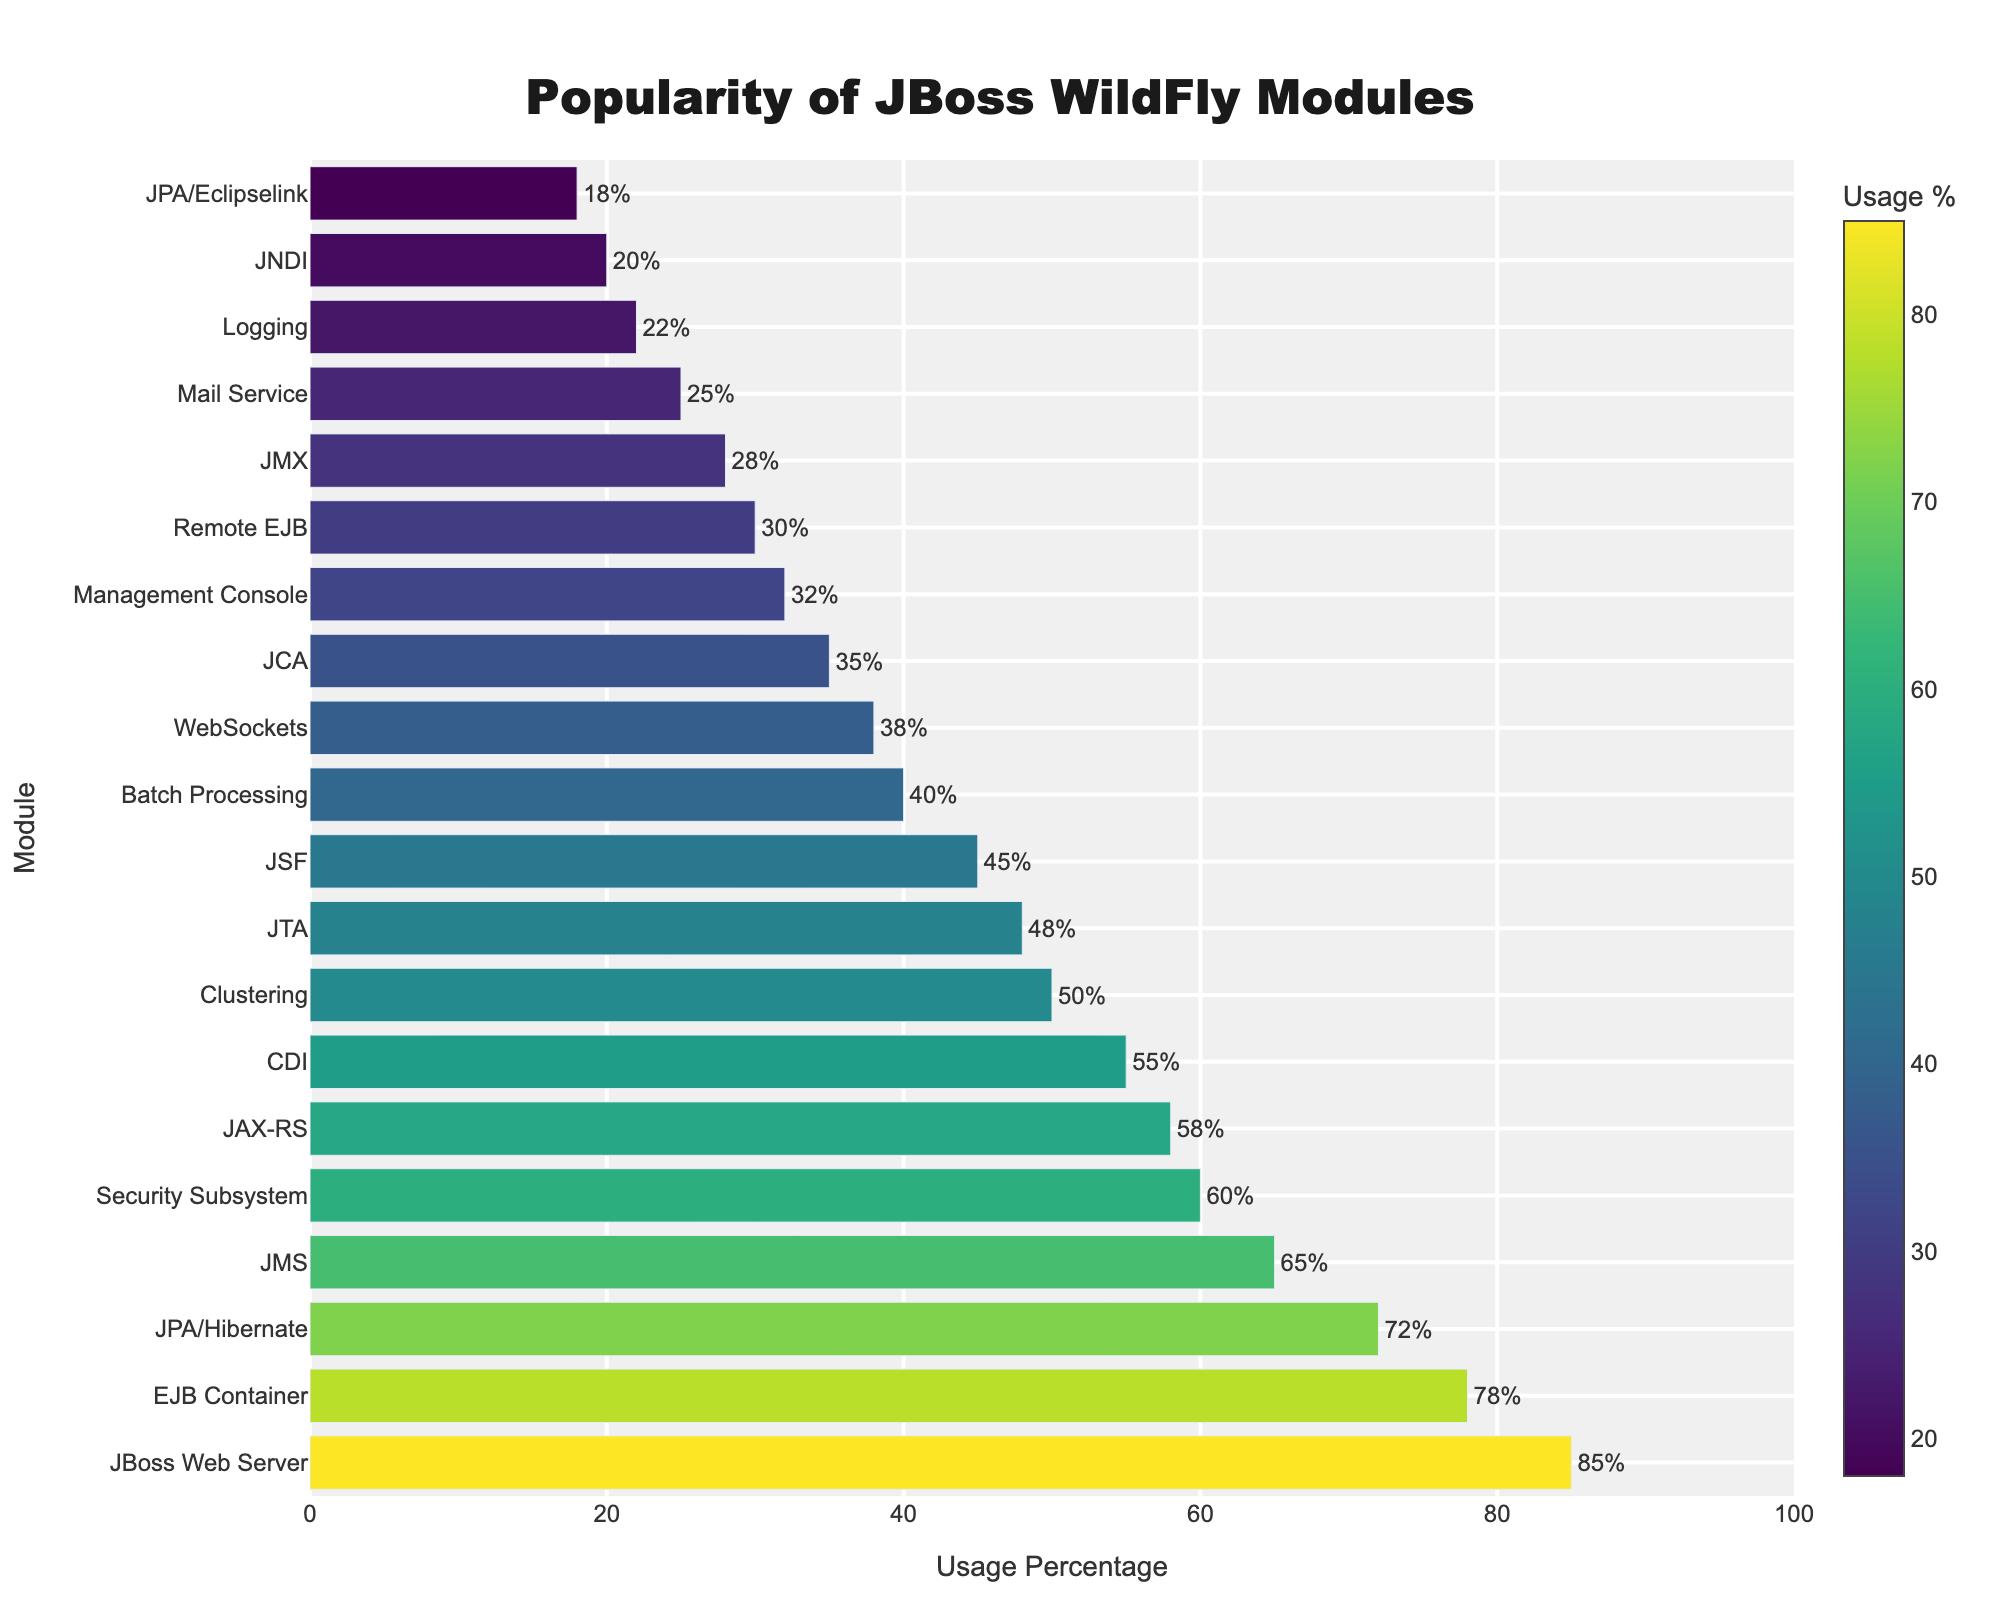Which module has the highest usage percentage? The JBoss Web Server module has the highest bar in the figure, indicating it has the highest usage percentage.
Answer: JBoss Web Server Which two modules have the closest usage percentages? By comparing the lengths of the bars, EJB Container (78%) and JPA/Hibernate (72%) have very close usage percentages.
Answer: EJB Container and JPA/Hibernate What's the difference in usage percentage between the top two most popular modules? The top two modules are JBoss Web Server (85%) and EJB Container (78%). The difference is 85 - 78 = 7%.
Answer: 7% How many modules have a usage percentage above 50%? From the figure, there are 6 bars with usage percentages above 50% (JBoss Web Server, EJB Container, JPA/Hibernate, JMS, Security Subsystem, JAX-RS).
Answer: 6 Are there more modules with usage below 40% or above 40%? By counting the bars, 8 modules have usage below 40% and 12 modules have usage above 40%.
Answer: Below 40% What's the average usage percentage of the top 3 most popular modules? The top 3 modules are JBoss Web Server (85%), EJB Container (78%), and JPA/Hibernate (72%). Their average is (85 + 78 + 72) / 3 = 235 / 3 ≈ 78.33.
Answer: 78.33 Which module has the lowest usage percentage, and what is it? The shortest bar represents JPA/Eclipselink with an 18% usage percentage.
Answer: JPA/Eclipselink, 18% What is the sum of the usage percentages of the modules in the middle of the list (7th to 10th)? The middle modules are CDI (55%), Clustering (50%), JTA (48%), and JSF (45%). The sum is 55 + 50 + 48 + 45 = 198.
Answer: 198 Which module's usage percentage is halfway between the highest and lowest percentages? The highest usage percentage is 85% and the lowest is 18%. The halfway point is (85 + 18) / 2 = 103 / 2 = 51.5. The module closest to 51.5% is Clustering (50%).
Answer: Clustering What is the usage percentage of the module represented by the second tallest bar? The second tallest bar corresponds to the EJB Container module with a 78% usage percentage.
Answer: 78% 